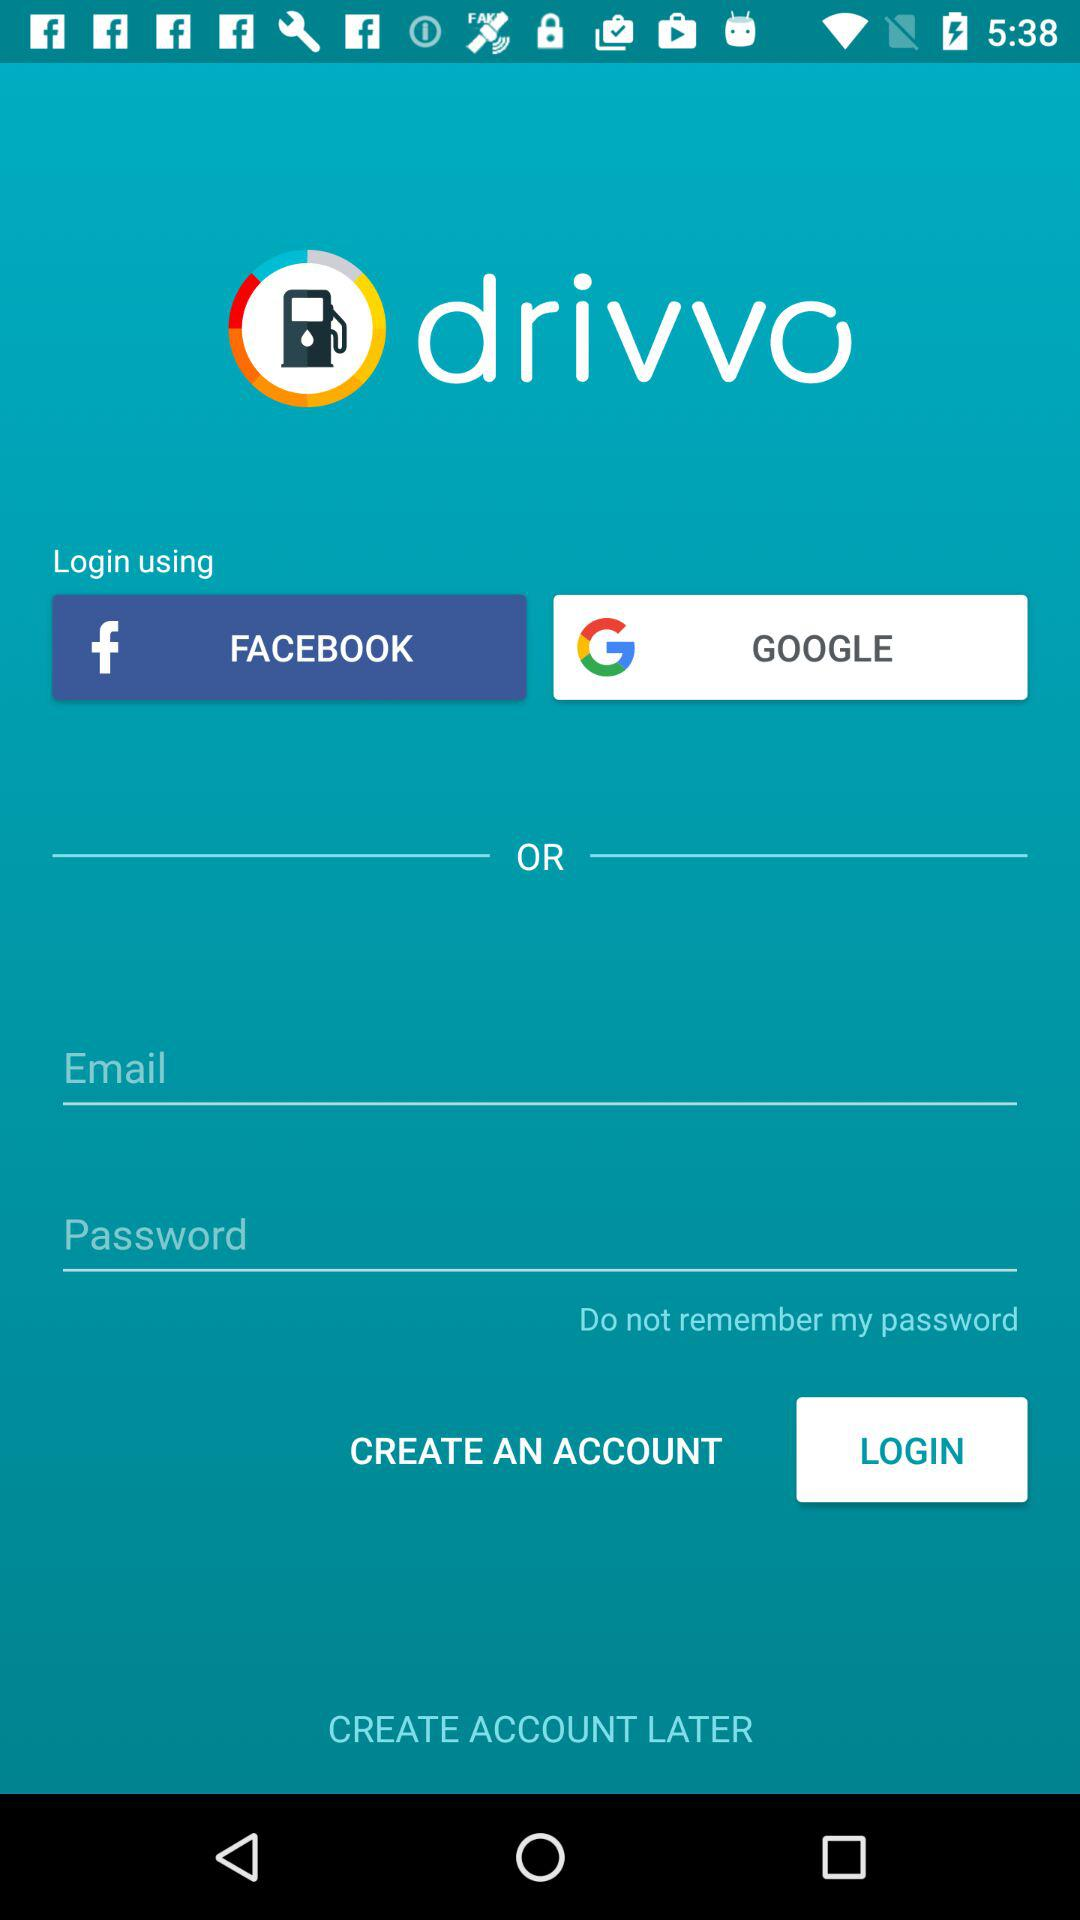What are the different login options? The different login options are :"FACEBOOK" and "GOOGLE". 